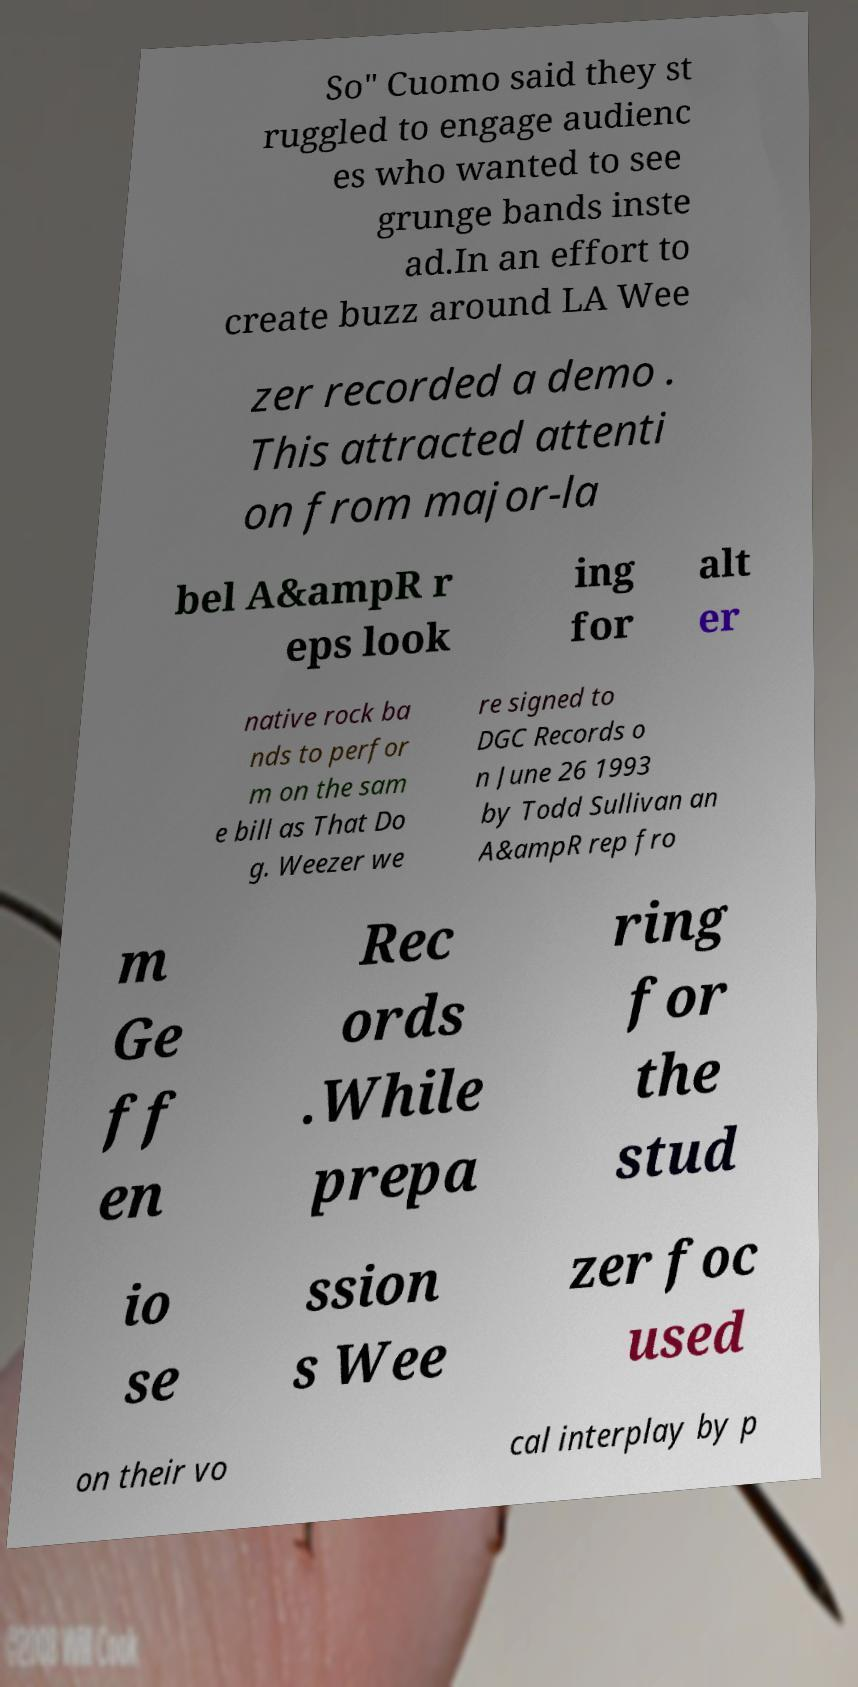Can you accurately transcribe the text from the provided image for me? So" Cuomo said they st ruggled to engage audienc es who wanted to see grunge bands inste ad.In an effort to create buzz around LA Wee zer recorded a demo . This attracted attenti on from major-la bel A&ampR r eps look ing for alt er native rock ba nds to perfor m on the sam e bill as That Do g. Weezer we re signed to DGC Records o n June 26 1993 by Todd Sullivan an A&ampR rep fro m Ge ff en Rec ords .While prepa ring for the stud io se ssion s Wee zer foc used on their vo cal interplay by p 